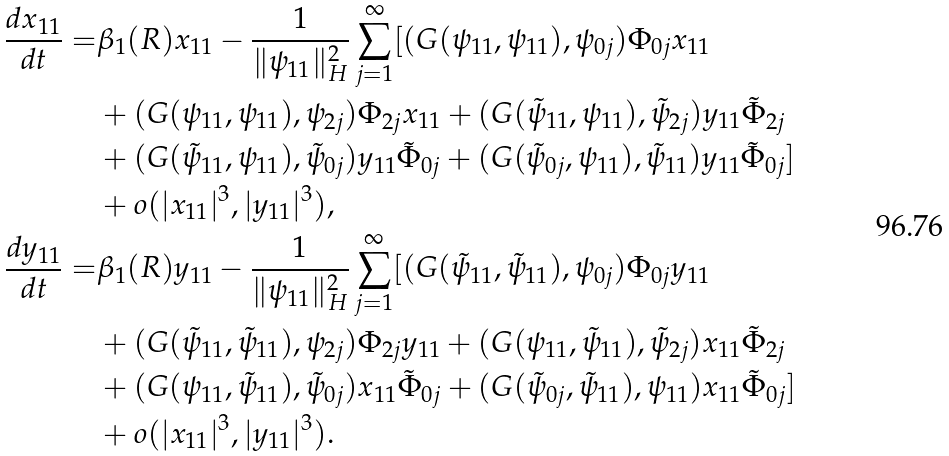Convert formula to latex. <formula><loc_0><loc_0><loc_500><loc_500>\frac { d x _ { 1 1 } } { d t } = & \beta _ { 1 } ( R ) x _ { 1 1 } - \frac { 1 } { \| \psi _ { 1 1 } \| ^ { 2 } _ { H } } \sum _ { j = 1 } ^ { \infty } [ ( G ( \psi _ { 1 1 } , \psi _ { 1 1 } ) , \psi _ { 0 j } ) \Phi _ { 0 j } x _ { 1 1 } \\ & + ( G ( \psi _ { 1 1 } , \psi _ { 1 1 } ) , \psi _ { 2 j } ) \Phi _ { 2 j } x _ { 1 1 } + ( G ( \tilde { \psi } _ { 1 1 } , \psi _ { 1 1 } ) , \tilde { \psi } _ { 2 j } ) y _ { 1 1 } \tilde { \Phi } _ { 2 j } \\ & + ( G ( \tilde { \psi } _ { 1 1 } , \psi _ { 1 1 } ) , \tilde { \psi } _ { 0 j } ) y _ { 1 1 } \tilde { \Phi } _ { 0 j } + ( G ( \tilde { \psi } _ { 0 j } , \psi _ { 1 1 } ) , \tilde { \psi } _ { 1 1 } ) y _ { 1 1 } \tilde { \Phi } _ { 0 j } ] \\ & + o ( | x _ { 1 1 } | ^ { 3 } , | y _ { 1 1 } | ^ { 3 } ) , \\ \frac { d y _ { 1 1 } } { d t } = & \beta _ { 1 } ( R ) y _ { 1 1 } - \frac { 1 } { \| \psi _ { 1 1 } \| ^ { 2 } _ { H } } \sum _ { j = 1 } ^ { \infty } [ ( G ( \tilde { \psi } _ { 1 1 } , \tilde { \psi } _ { 1 1 } ) , \psi _ { 0 j } ) \Phi _ { 0 j } y _ { 1 1 } \\ & + ( G ( \tilde { \psi } _ { 1 1 } , \tilde { \psi } _ { 1 1 } ) , \psi _ { 2 j } ) \Phi _ { 2 j } y _ { 1 1 } + ( G ( \psi _ { 1 1 } , \tilde { \psi } _ { 1 1 } ) , \tilde { \psi } _ { 2 j } ) x _ { 1 1 } \tilde { \Phi } _ { 2 j } \\ & + ( G ( \psi _ { 1 1 } , \tilde { \psi } _ { 1 1 } ) , \tilde { \psi } _ { 0 j } ) x _ { 1 1 } \tilde { \Phi } _ { 0 j } + ( G ( \tilde { \psi } _ { 0 j } , \tilde { \psi } _ { 1 1 } ) , \psi _ { 1 1 } ) x _ { 1 1 } \tilde { \Phi } _ { 0 j } ] \\ & + o ( | x _ { 1 1 } | ^ { 3 } , | y _ { 1 1 } | ^ { 3 } ) .</formula> 